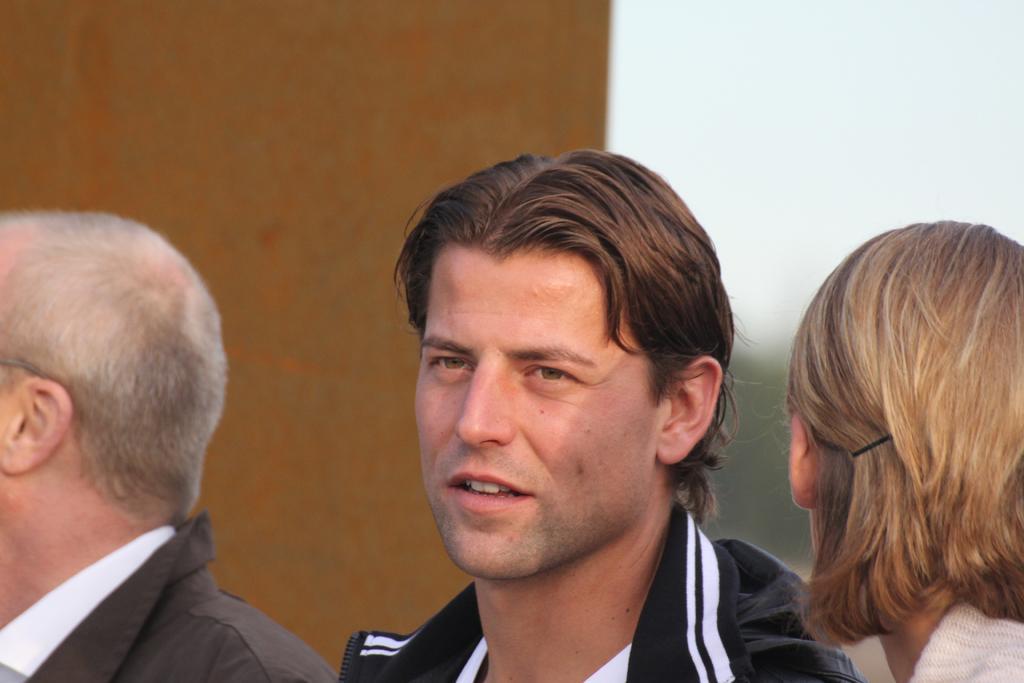Please provide a concise description of this image. In the foreground of the image there are people. In the background of the image there is a wall. 